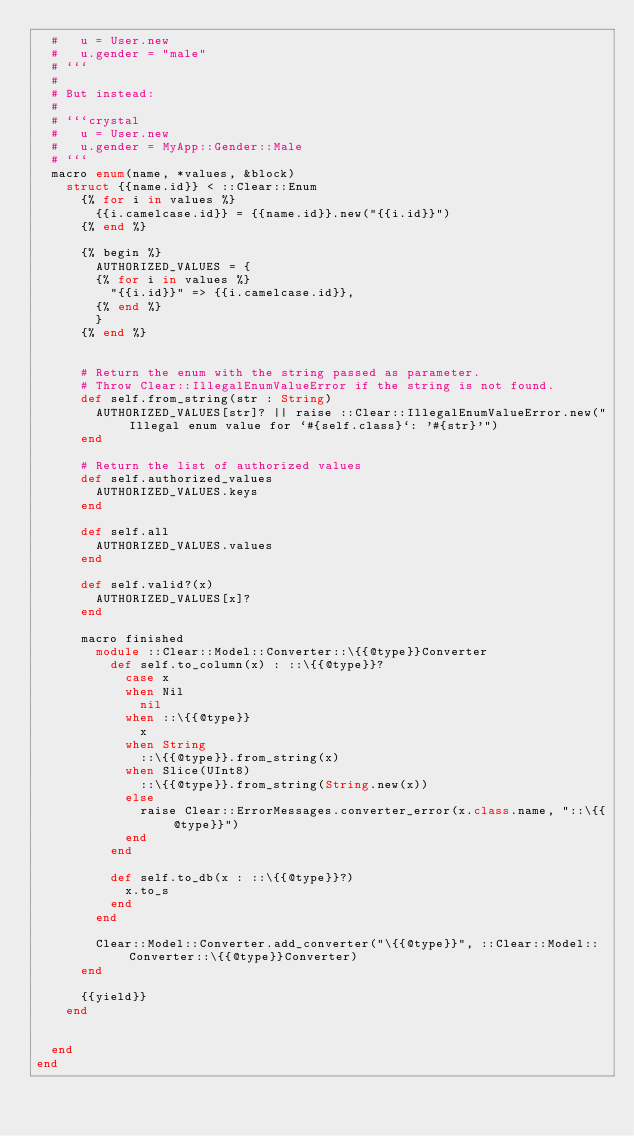<code> <loc_0><loc_0><loc_500><loc_500><_Crystal_>  #   u = User.new
  #   u.gender = "male"
  # ```
  #
  # But instead:
  #
  # ```crystal
  #   u = User.new
  #   u.gender = MyApp::Gender::Male
  # ```
  macro enum(name, *values, &block)
    struct {{name.id}} < ::Clear::Enum
      {% for i in values %}
        {{i.camelcase.id}} = {{name.id}}.new("{{i.id}}")
      {% end %}

      {% begin %}
        AUTHORIZED_VALUES = {
        {% for i in values %}
          "{{i.id}}" => {{i.camelcase.id}},
        {% end %}
        }
      {% end %}


      # Return the enum with the string passed as parameter.
      # Throw Clear::IllegalEnumValueError if the string is not found.
      def self.from_string(str : String)
        AUTHORIZED_VALUES[str]? || raise ::Clear::IllegalEnumValueError.new("Illegal enum value for `#{self.class}`: '#{str}'")
      end

      # Return the list of authorized values
      def self.authorized_values
        AUTHORIZED_VALUES.keys
      end

      def self.all
        AUTHORIZED_VALUES.values
      end

      def self.valid?(x)
        AUTHORIZED_VALUES[x]?
      end

      macro finished
        module ::Clear::Model::Converter::\{{@type}}Converter
          def self.to_column(x) : ::\{{@type}}?
            case x
            when Nil
              nil
            when ::\{{@type}}
              x
            when String
              ::\{{@type}}.from_string(x)
            when Slice(UInt8)
              ::\{{@type}}.from_string(String.new(x))
            else
              raise Clear::ErrorMessages.converter_error(x.class.name, "::\{{@type}}")
            end
          end

          def self.to_db(x : ::\{{@type}}?)
            x.to_s
          end
        end

        Clear::Model::Converter.add_converter("\{{@type}}", ::Clear::Model::Converter::\{{@type}}Converter)
      end

      {{yield}}
    end


  end
end
</code> 